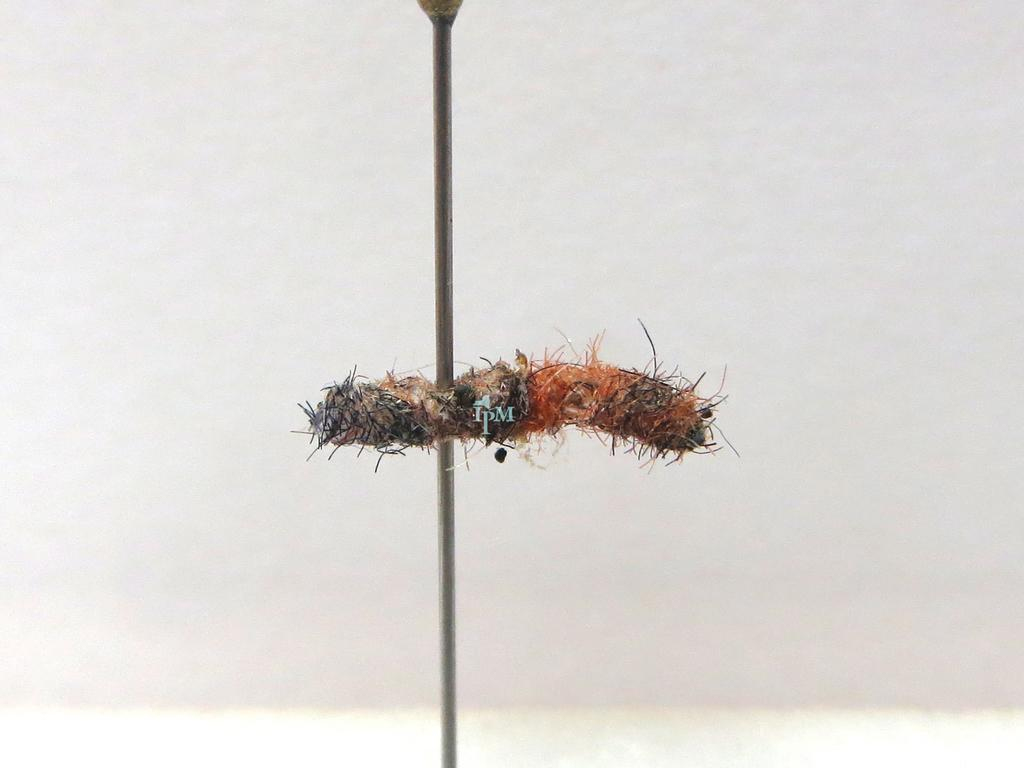What is on the metal pole in the image? There is an object on a metal pole in the image. Can you describe the colors of the object? The object has orange, cream, and black colors. What is the color of the background in the image? The background of the image is white. How does the object on the metal pole perform magic in the image? There is no indication of magic or any magical properties in the image; it simply shows an object on a metal pole with specific colors. 